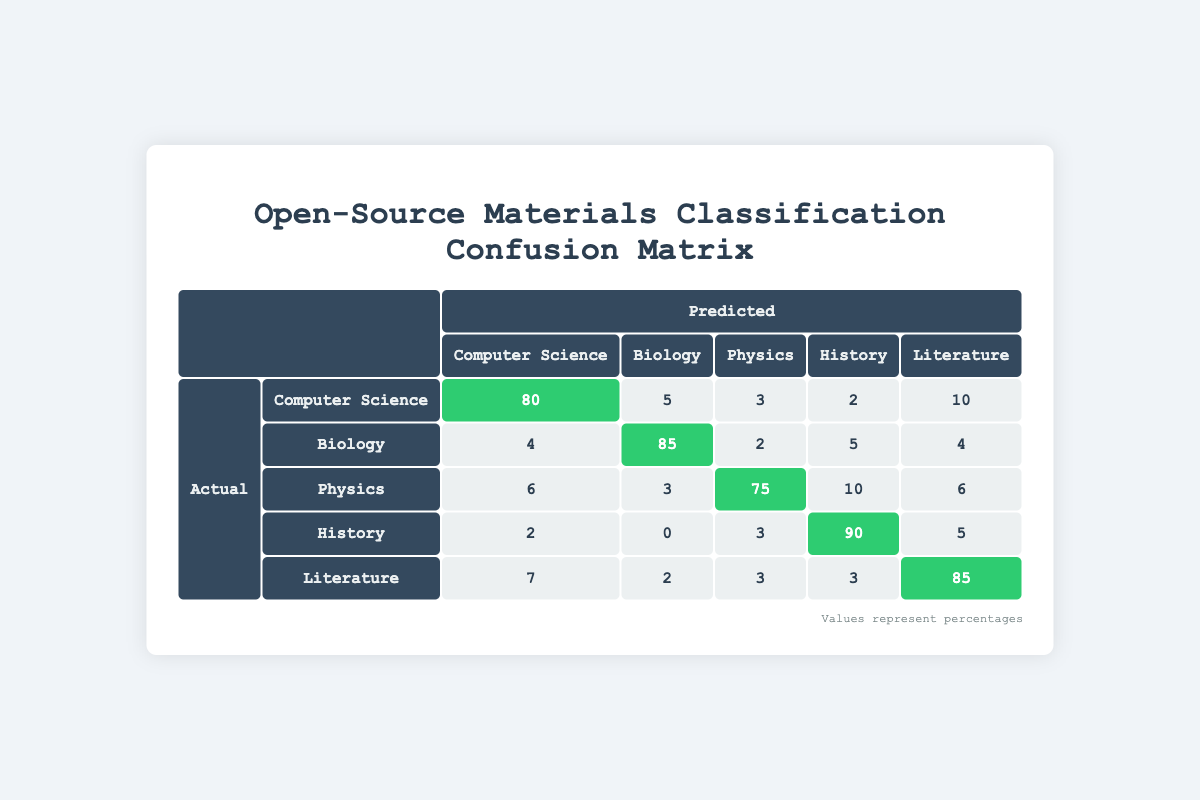What is the number of actual Computer Science materials predicted correctly? In the confusion matrix, looking at the row for Computer Science under the actual column, the value corresponding to the predicted Computer Science is 80.
Answer: 80 What percentage of Biology materials were misclassified as Computer Science? The number of actual Biology materials predicted as Computer Science is 4. To find the percentage, divide this by the total actual Biology materials, which is 85 (predicted correctly) + 4 (misclassified) + 2 + 5 + 4 = 100. Thus, the percentage is (4/100) * 100 = 4%.
Answer: 4% Is it true that more Literature materials were predicted as Physics than as History? The number of actual Literature materials predicted as Physics is 3 and predicted as History is 3 as well. Since both values are equal, the statement is false.
Answer: No What is the total number of actual Physics materials predicted incorrectly? To find this, we add the numbers in the Physics row excluding the correctly predicted value: 6 (Computer Science) + 3 (Biology) + 10 (History) + 6 (Literature) = 25. Thus, the total number of incorrectly predicted Physics materials is 25.
Answer: 25 What is the average number of materials predicted correctly across all subject areas? The total number of correctly predicted materials is 80 (Computer Science) + 85 (Biology) + 75 (Physics) + 90 (History) + 85 (Literature) = 415. There are 5 subject areas, so the average is 415/5 = 83.
Answer: 83 How many predicted errors occurred in the History category? In the confusion matrix, the number of actual History materials predicted incorrectly is the sum of the values in the History row excluding the predicted History value: 2 (Computer Science) + 0 (Biology) + 3 (Physics) + 5 (Literature) = 10.
Answer: 10 What subject area has the lowest number of correct predictions? By looking at the diagonal values of the confusion matrix, the subject area with the lowest correct predictions is Physics, with 75.
Answer: Physics What is the total count of all materials predicted as Literature? Summing up the values in the predicted Literature column: 10 (Computer Science) + 4 (Biology) + 6 (Physics) + 5 (History) + 85 (Literature) = 110.
Answer: 110 